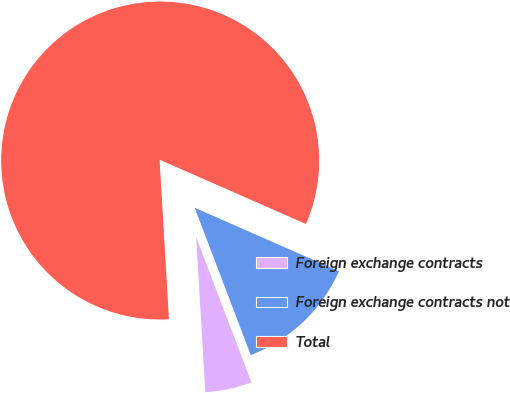Convert chart to OTSL. <chart><loc_0><loc_0><loc_500><loc_500><pie_chart><fcel>Foreign exchange contracts<fcel>Foreign exchange contracts not<fcel>Total<nl><fcel>4.85%<fcel>12.62%<fcel>82.52%<nl></chart> 